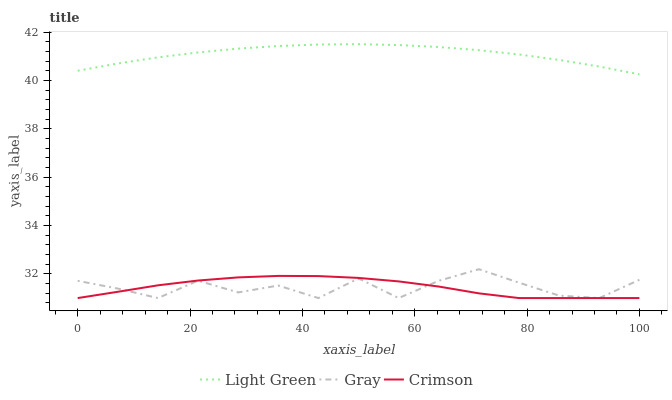Does Gray have the minimum area under the curve?
Answer yes or no. Yes. Does Light Green have the maximum area under the curve?
Answer yes or no. Yes. Does Light Green have the minimum area under the curve?
Answer yes or no. No. Does Gray have the maximum area under the curve?
Answer yes or no. No. Is Light Green the smoothest?
Answer yes or no. Yes. Is Gray the roughest?
Answer yes or no. Yes. Is Gray the smoothest?
Answer yes or no. No. Is Light Green the roughest?
Answer yes or no. No. Does Light Green have the lowest value?
Answer yes or no. No. Does Gray have the highest value?
Answer yes or no. No. Is Gray less than Light Green?
Answer yes or no. Yes. Is Light Green greater than Gray?
Answer yes or no. Yes. Does Gray intersect Light Green?
Answer yes or no. No. 